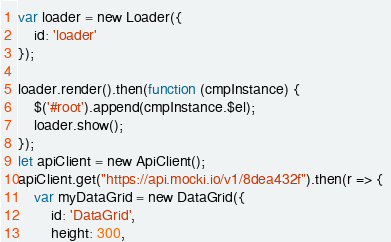Convert code to text. <code><loc_0><loc_0><loc_500><loc_500><_JavaScript_>var loader = new Loader({
    id: 'loader'
});

loader.render().then(function (cmpInstance) {
    $('#root').append(cmpInstance.$el);
    loader.show();
});
let apiClient = new ApiClient();
apiClient.get("https://api.mocki.io/v1/8dea432f").then(r => { 
    var myDataGrid = new DataGrid({
        id: 'DataGrid',
        height: 300,</code> 